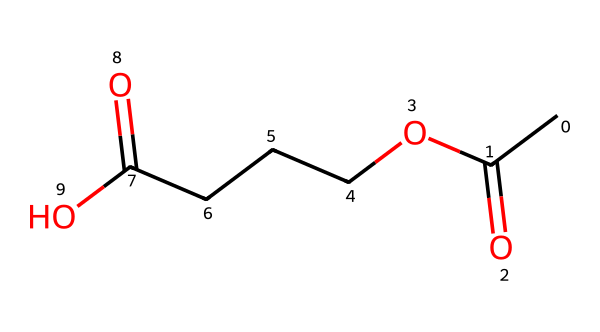What is the functional group present in this molecule? The molecule features a carboxylic acid group (CC(=O)O), which includes a carbon atom double bonded to an oxygen atom and single bonded to a hydroxyl group.
Answer: carboxylic acid How many carbon atoms are in this molecule? By analyzing the SMILES, there are five 'C' letters representing five carbon atoms in total.
Answer: five What type of bond connects the carbon atoms in the backbone? The primary connections between the carbon atoms are single bonds, allowing the chain to be flexible and structured like typical organic compounds.
Answer: single bonds What is one potential use of this chemical in clothing materials? This chemical structure implies it can be used to create synthetic fibers due to its properties, which allow for durability and flexibility, making it suitable for various textiles.
Answer: synthetic fibers How many carboxylic acid groups are in this molecule? Counting the -COOH groups depicted in the SMILES shows two distinct carboxylic acid groups attached to the chain.
Answer: two What type of polymer is this molecule associated with? The structure aligns with polyesters or polyamides, due to the presence of ester linkages that could occur during polymerization, relevant in synthetic fibers.
Answer: polyester 